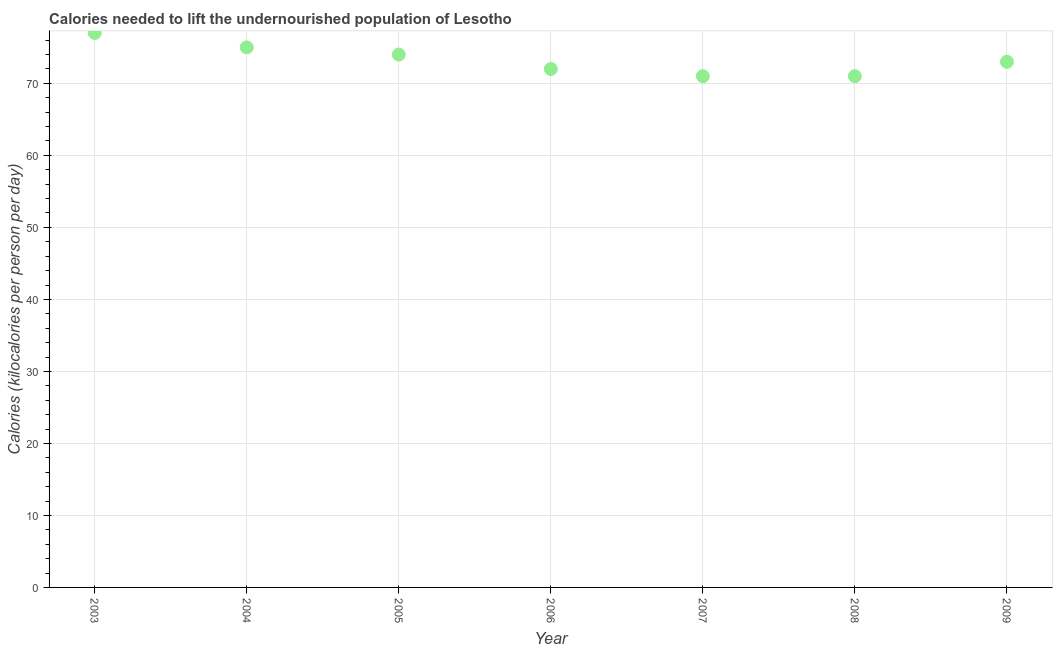What is the depth of food deficit in 2006?
Keep it short and to the point. 72. Across all years, what is the maximum depth of food deficit?
Keep it short and to the point. 77. Across all years, what is the minimum depth of food deficit?
Ensure brevity in your answer.  71. What is the sum of the depth of food deficit?
Offer a terse response. 513. What is the difference between the depth of food deficit in 2007 and 2008?
Your response must be concise. 0. What is the average depth of food deficit per year?
Your response must be concise. 73.29. What is the median depth of food deficit?
Your answer should be compact. 73. Do a majority of the years between 2006 and 2008 (inclusive) have depth of food deficit greater than 18 kilocalories?
Offer a terse response. Yes. What is the ratio of the depth of food deficit in 2004 to that in 2006?
Keep it short and to the point. 1.04. Is the depth of food deficit in 2003 less than that in 2006?
Keep it short and to the point. No. Is the difference between the depth of food deficit in 2005 and 2009 greater than the difference between any two years?
Keep it short and to the point. No. Is the sum of the depth of food deficit in 2006 and 2009 greater than the maximum depth of food deficit across all years?
Give a very brief answer. Yes. What is the difference between the highest and the lowest depth of food deficit?
Keep it short and to the point. 6. In how many years, is the depth of food deficit greater than the average depth of food deficit taken over all years?
Your answer should be very brief. 3. Does the depth of food deficit monotonically increase over the years?
Make the answer very short. No. How many years are there in the graph?
Give a very brief answer. 7. Does the graph contain any zero values?
Provide a short and direct response. No. Does the graph contain grids?
Offer a terse response. Yes. What is the title of the graph?
Your response must be concise. Calories needed to lift the undernourished population of Lesotho. What is the label or title of the Y-axis?
Offer a terse response. Calories (kilocalories per person per day). What is the Calories (kilocalories per person per day) in 2004?
Provide a succinct answer. 75. What is the Calories (kilocalories per person per day) in 2005?
Your response must be concise. 74. What is the Calories (kilocalories per person per day) in 2008?
Give a very brief answer. 71. What is the difference between the Calories (kilocalories per person per day) in 2003 and 2004?
Make the answer very short. 2. What is the difference between the Calories (kilocalories per person per day) in 2003 and 2005?
Give a very brief answer. 3. What is the difference between the Calories (kilocalories per person per day) in 2003 and 2006?
Your response must be concise. 5. What is the difference between the Calories (kilocalories per person per day) in 2003 and 2007?
Provide a succinct answer. 6. What is the difference between the Calories (kilocalories per person per day) in 2003 and 2008?
Provide a short and direct response. 6. What is the difference between the Calories (kilocalories per person per day) in 2003 and 2009?
Offer a terse response. 4. What is the difference between the Calories (kilocalories per person per day) in 2004 and 2005?
Your answer should be very brief. 1. What is the difference between the Calories (kilocalories per person per day) in 2005 and 2008?
Provide a succinct answer. 3. What is the difference between the Calories (kilocalories per person per day) in 2005 and 2009?
Give a very brief answer. 1. What is the difference between the Calories (kilocalories per person per day) in 2006 and 2007?
Your answer should be compact. 1. What is the difference between the Calories (kilocalories per person per day) in 2006 and 2008?
Your answer should be compact. 1. What is the difference between the Calories (kilocalories per person per day) in 2006 and 2009?
Offer a very short reply. -1. What is the difference between the Calories (kilocalories per person per day) in 2007 and 2009?
Your answer should be very brief. -2. What is the ratio of the Calories (kilocalories per person per day) in 2003 to that in 2004?
Ensure brevity in your answer.  1.03. What is the ratio of the Calories (kilocalories per person per day) in 2003 to that in 2005?
Provide a short and direct response. 1.04. What is the ratio of the Calories (kilocalories per person per day) in 2003 to that in 2006?
Your answer should be compact. 1.07. What is the ratio of the Calories (kilocalories per person per day) in 2003 to that in 2007?
Ensure brevity in your answer.  1.08. What is the ratio of the Calories (kilocalories per person per day) in 2003 to that in 2008?
Your answer should be very brief. 1.08. What is the ratio of the Calories (kilocalories per person per day) in 2003 to that in 2009?
Your response must be concise. 1.05. What is the ratio of the Calories (kilocalories per person per day) in 2004 to that in 2006?
Make the answer very short. 1.04. What is the ratio of the Calories (kilocalories per person per day) in 2004 to that in 2007?
Offer a very short reply. 1.06. What is the ratio of the Calories (kilocalories per person per day) in 2004 to that in 2008?
Offer a very short reply. 1.06. What is the ratio of the Calories (kilocalories per person per day) in 2004 to that in 2009?
Your answer should be very brief. 1.03. What is the ratio of the Calories (kilocalories per person per day) in 2005 to that in 2006?
Give a very brief answer. 1.03. What is the ratio of the Calories (kilocalories per person per day) in 2005 to that in 2007?
Give a very brief answer. 1.04. What is the ratio of the Calories (kilocalories per person per day) in 2005 to that in 2008?
Provide a short and direct response. 1.04. What is the ratio of the Calories (kilocalories per person per day) in 2006 to that in 2008?
Provide a succinct answer. 1.01. What is the ratio of the Calories (kilocalories per person per day) in 2006 to that in 2009?
Your answer should be very brief. 0.99. What is the ratio of the Calories (kilocalories per person per day) in 2007 to that in 2008?
Provide a short and direct response. 1. What is the ratio of the Calories (kilocalories per person per day) in 2008 to that in 2009?
Your response must be concise. 0.97. 